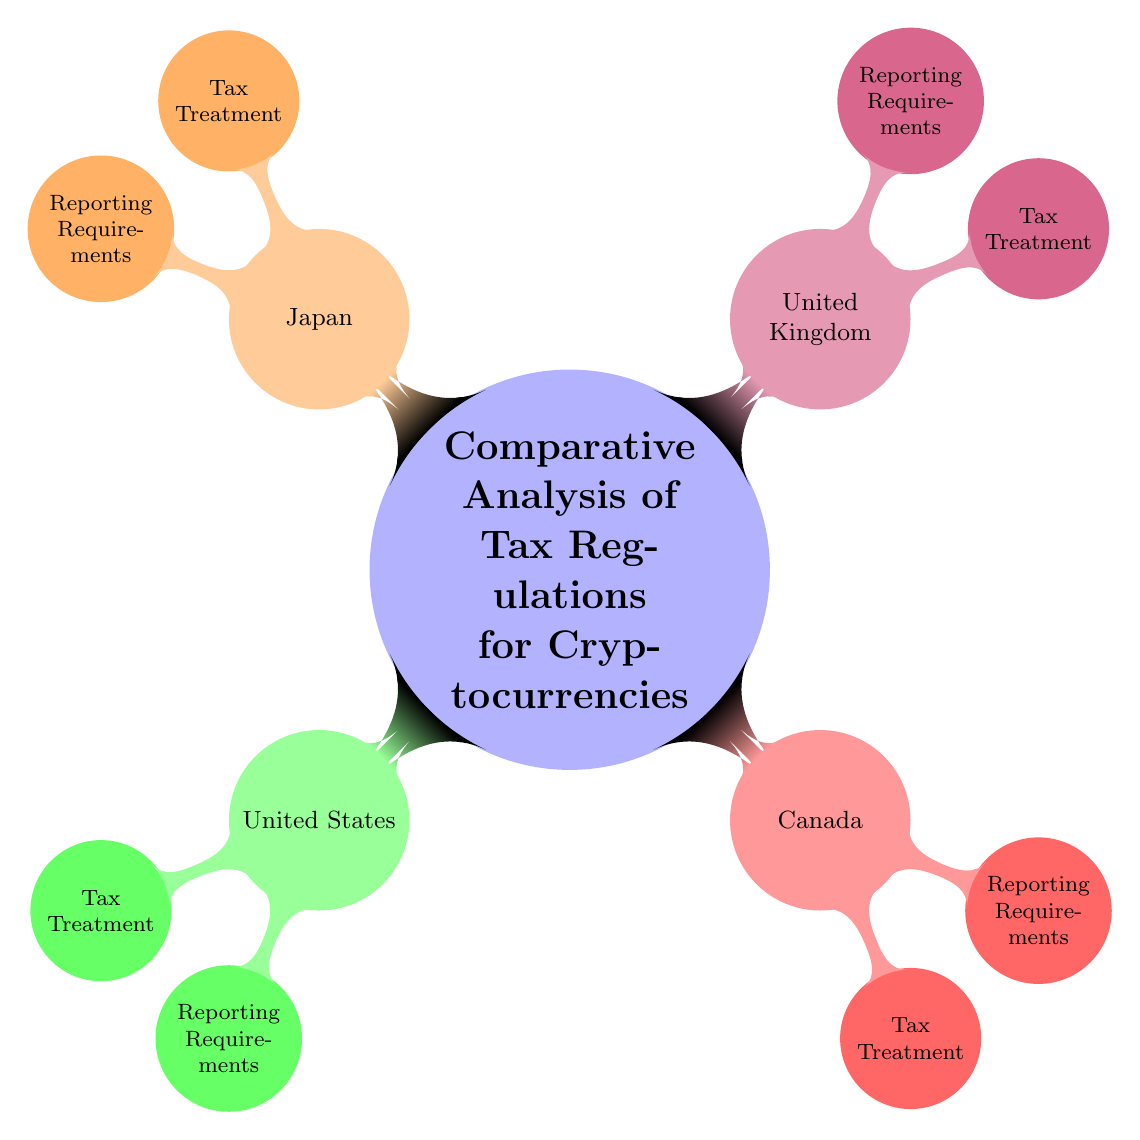What's the main topic of the diagram? The central node clearly states the main topic as "Comparative Analysis of Tax Regulations for Cryptocurrencies."
Answer: Comparative Analysis of Tax Regulations for Cryptocurrencies How many countries are represented in the diagram? The diagram lists four distinct countries: United States, Canada, United Kingdom, and Japan, which are all visualized as individual child nodes.
Answer: Four What are the two subcategories under each country's legislation? Each country has two subcategories listed: "Tax Treatment" and "Reporting Requirements," appearing as child nodes under each respective country.
Answer: Tax Treatment and Reporting Requirements Which country is colored red in the diagram? The country represented in red is Canada, as indicated by the color scheme assigned to the nodes in the diagram.
Answer: Canada What is the relationship between the concepts of Tax Treatment and Reporting Requirements for each country? The diagram shows that both "Tax Treatment" and "Reporting Requirements" are directly linked as sub-nodes under each country's primary node, highlighting a parallel structure across all countries.
Answer: They are sub-nodes of their respective countries Explain the color coding in the diagram and its significance. Each country is assigned a unique color scheme, which helps visually differentiate them. It maintains an organized structure and allows for quick identification of the content related to each country without confusion.
Answer: Unique color scheme for each country Which country has the first listed node in the diagram? The first country listed is the United States, appearing first among the child nodes that branch out from the central node.
Answer: United States What does the term "mindmap" indicate about the structure of this diagram? The term "mindmap" suggests a hierarchical layout where the main idea is at the center, and related concepts branch out in a radial manner, showcasing connections among ideas clearly.
Answer: Hierarchical layout with a central topic 